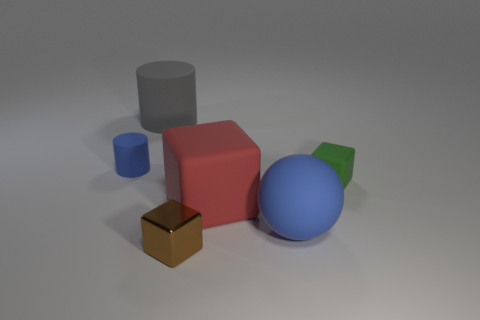Can you describe the composition of shapes and colors in this image? Certainly, the image showcases a collection of geometric shapes in a simple 3D space. There's a large red cube slightly off-center, surrounded by a big blue sphere, a smaller green cube, and two cylinders, one larger and gray, the other smaller and blue. A small brown cube sits in front of these shapes. Their arrangement and the subdued background suggest a calm and ordered scene with a harmonious blend of colors. 